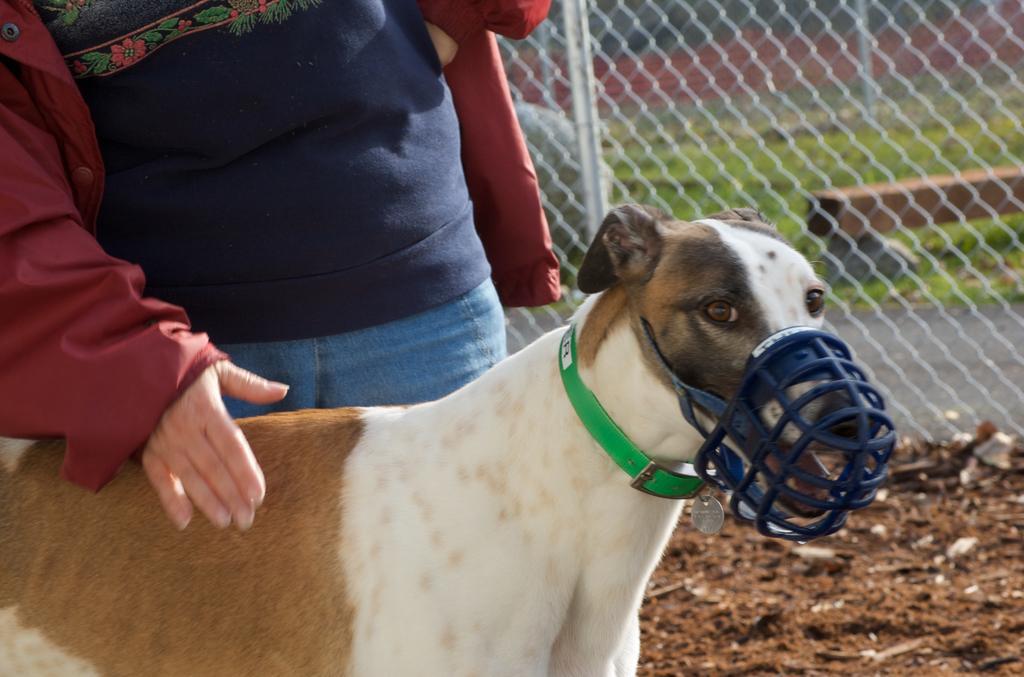In one or two sentences, can you explain what this image depicts? This image consists of a dog in white and brown color. Beside that there is a person standing is wearing red jacket. At the bottom, there is ground. In the background, there is a fencing. 